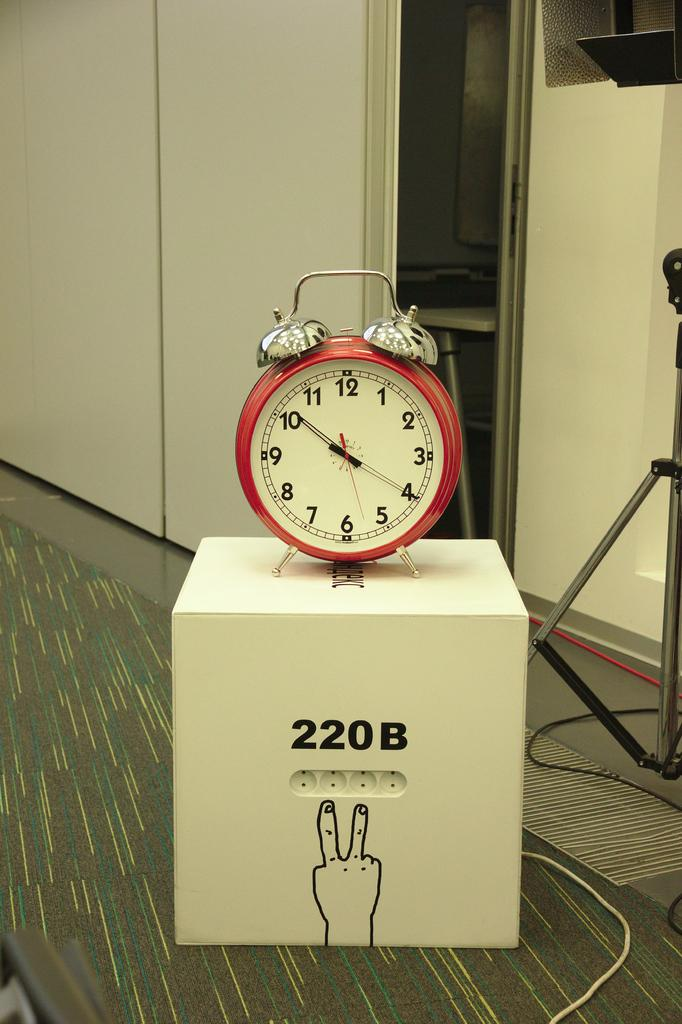Provide a one-sentence caption for the provided image. a red alarm clock on a box with 220B on it. 